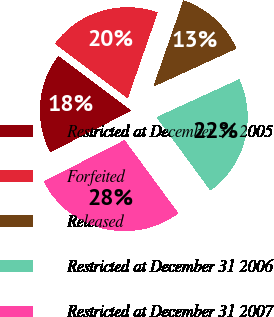Convert chart. <chart><loc_0><loc_0><loc_500><loc_500><pie_chart><fcel>Restricted at December 31 2005<fcel>Forfeited<fcel>Released<fcel>Restricted at December 31 2006<fcel>Restricted at December 31 2007<nl><fcel>17.8%<fcel>20.08%<fcel>12.83%<fcel>21.76%<fcel>27.54%<nl></chart> 